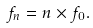Convert formula to latex. <formula><loc_0><loc_0><loc_500><loc_500>f _ { n } = n \times f _ { 0 } .</formula> 